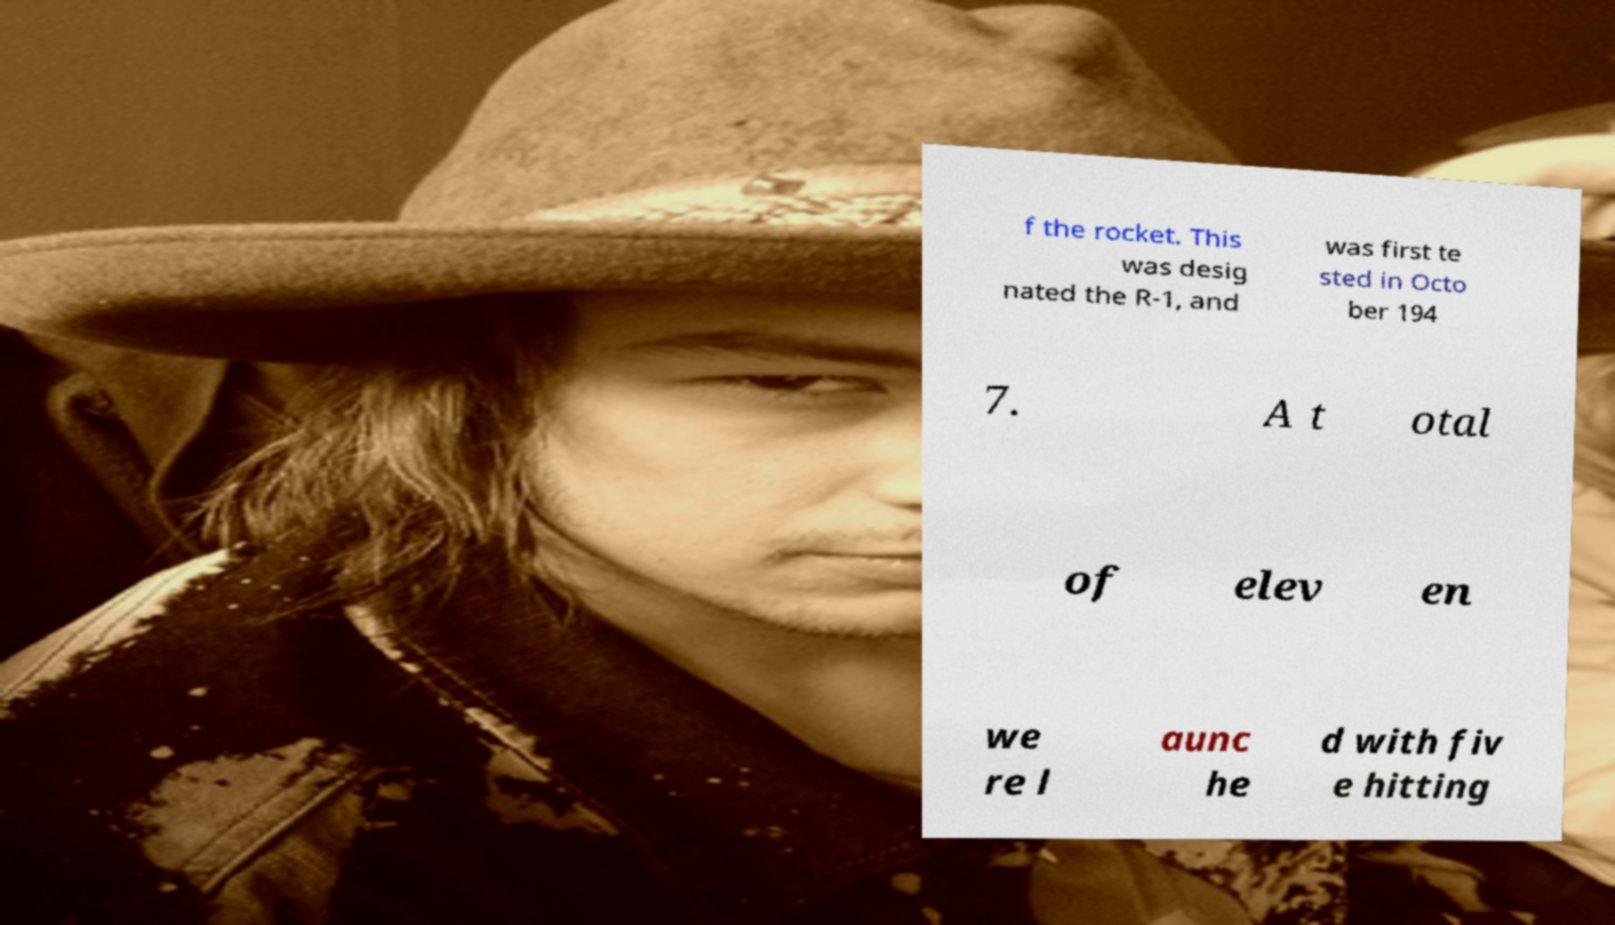Please read and relay the text visible in this image. What does it say? f the rocket. This was desig nated the R-1, and was first te sted in Octo ber 194 7. A t otal of elev en we re l aunc he d with fiv e hitting 